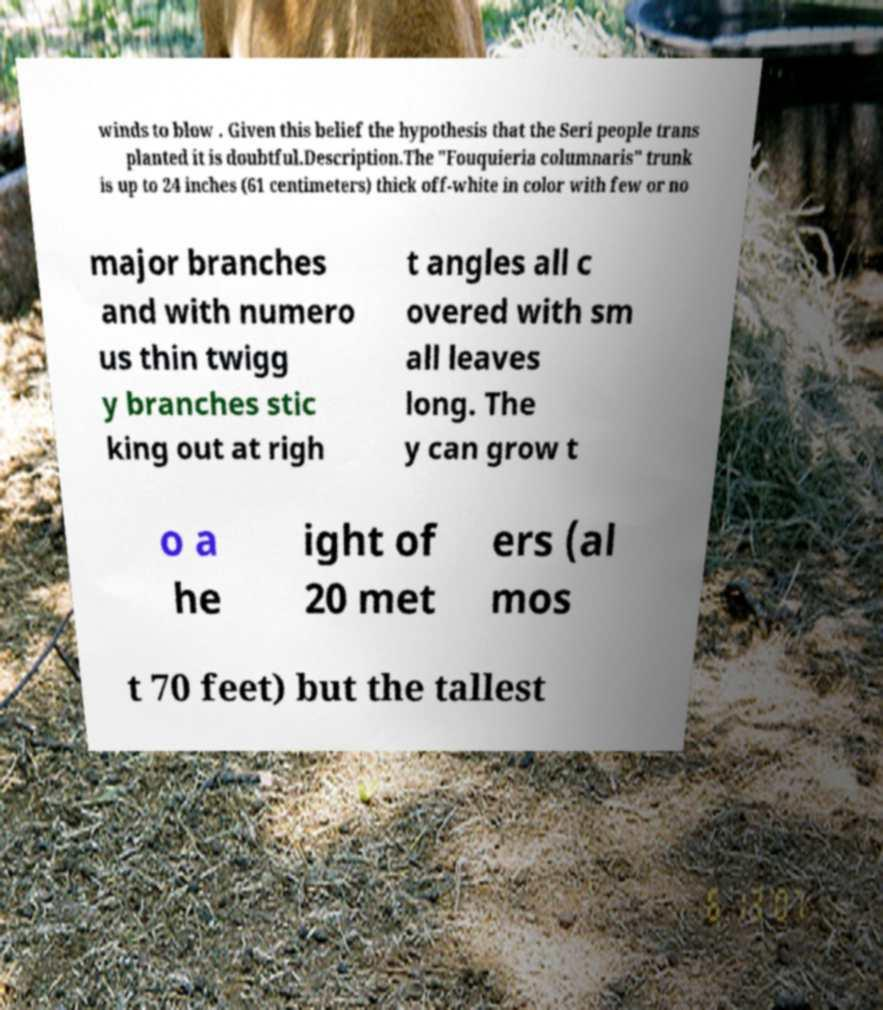Please identify and transcribe the text found in this image. winds to blow . Given this belief the hypothesis that the Seri people trans planted it is doubtful.Description.The "Fouquieria columnaris" trunk is up to 24 inches (61 centimeters) thick off-white in color with few or no major branches and with numero us thin twigg y branches stic king out at righ t angles all c overed with sm all leaves long. The y can grow t o a he ight of 20 met ers (al mos t 70 feet) but the tallest 